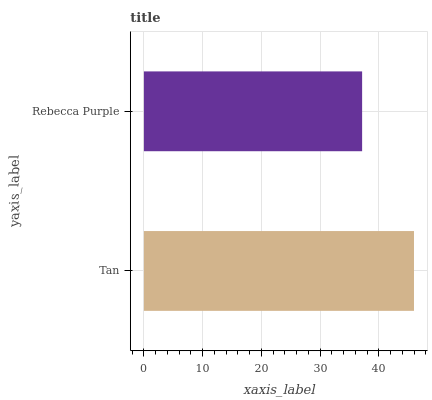Is Rebecca Purple the minimum?
Answer yes or no. Yes. Is Tan the maximum?
Answer yes or no. Yes. Is Rebecca Purple the maximum?
Answer yes or no. No. Is Tan greater than Rebecca Purple?
Answer yes or no. Yes. Is Rebecca Purple less than Tan?
Answer yes or no. Yes. Is Rebecca Purple greater than Tan?
Answer yes or no. No. Is Tan less than Rebecca Purple?
Answer yes or no. No. Is Tan the high median?
Answer yes or no. Yes. Is Rebecca Purple the low median?
Answer yes or no. Yes. Is Rebecca Purple the high median?
Answer yes or no. No. Is Tan the low median?
Answer yes or no. No. 